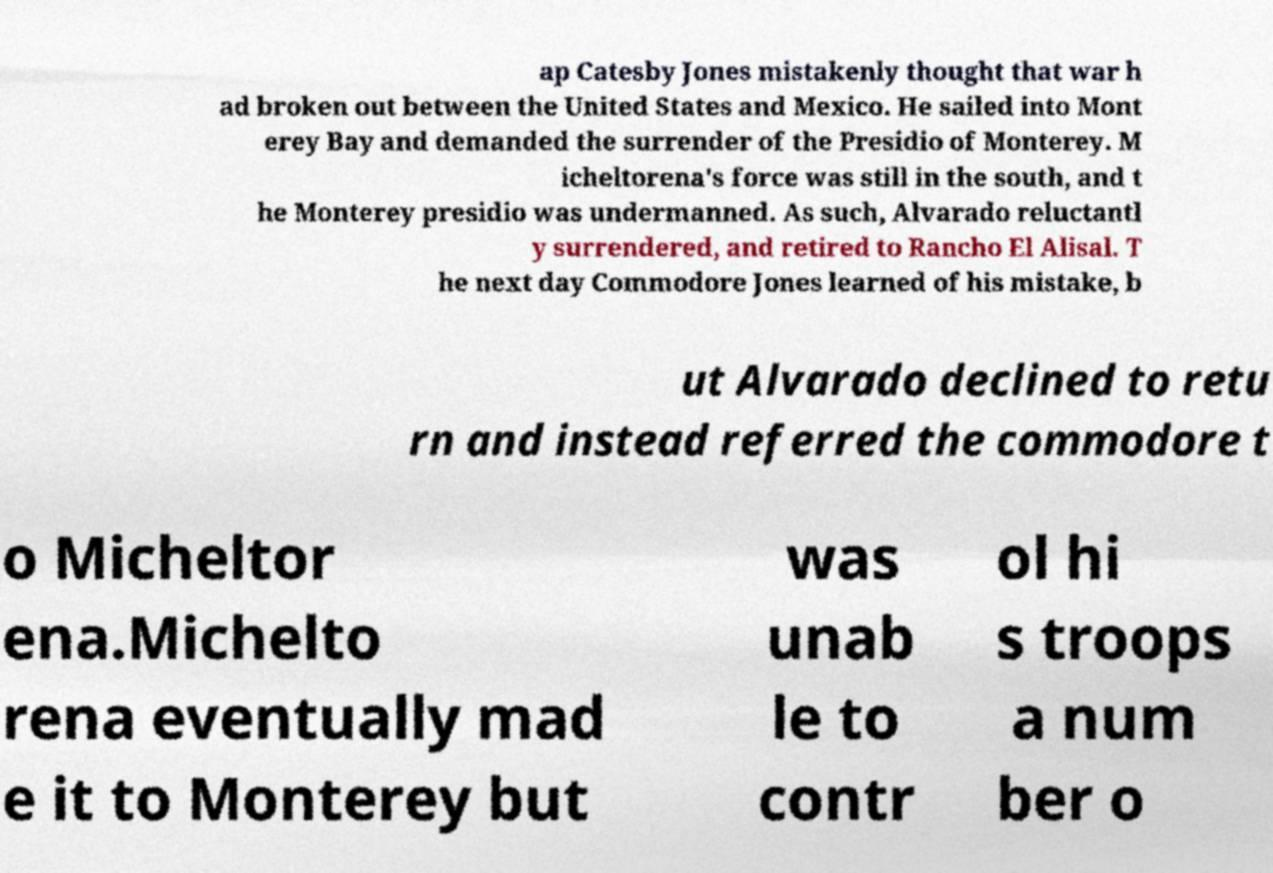I need the written content from this picture converted into text. Can you do that? ap Catesby Jones mistakenly thought that war h ad broken out between the United States and Mexico. He sailed into Mont erey Bay and demanded the surrender of the Presidio of Monterey. M icheltorena's force was still in the south, and t he Monterey presidio was undermanned. As such, Alvarado reluctantl y surrendered, and retired to Rancho El Alisal. T he next day Commodore Jones learned of his mistake, b ut Alvarado declined to retu rn and instead referred the commodore t o Micheltor ena.Michelto rena eventually mad e it to Monterey but was unab le to contr ol hi s troops a num ber o 